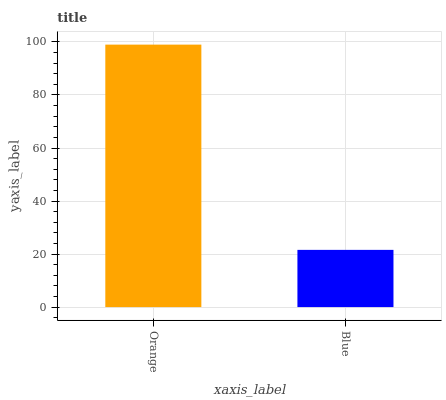Is Blue the minimum?
Answer yes or no. Yes. Is Orange the maximum?
Answer yes or no. Yes. Is Blue the maximum?
Answer yes or no. No. Is Orange greater than Blue?
Answer yes or no. Yes. Is Blue less than Orange?
Answer yes or no. Yes. Is Blue greater than Orange?
Answer yes or no. No. Is Orange less than Blue?
Answer yes or no. No. Is Orange the high median?
Answer yes or no. Yes. Is Blue the low median?
Answer yes or no. Yes. Is Blue the high median?
Answer yes or no. No. Is Orange the low median?
Answer yes or no. No. 